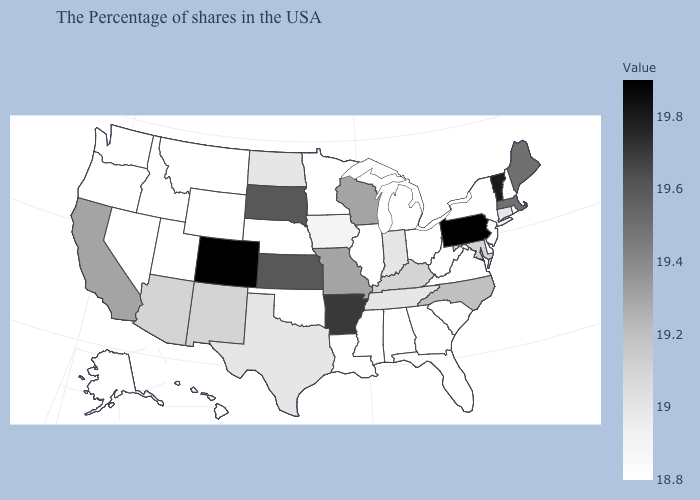Which states have the highest value in the USA?
Answer briefly. Pennsylvania, Colorado. Does South Dakota have the highest value in the MidWest?
Short answer required. Yes. Among the states that border West Virginia , does Kentucky have the highest value?
Be succinct. No. Does Idaho have the lowest value in the USA?
Short answer required. Yes. Does Georgia have the lowest value in the South?
Be succinct. Yes. Does Alaska have the lowest value in the USA?
Short answer required. Yes. Does Connecticut have the lowest value in the Northeast?
Concise answer only. No. Does Alaska have the highest value in the USA?
Give a very brief answer. No. Which states hav the highest value in the MidWest?
Write a very short answer. Kansas, South Dakota. Which states have the lowest value in the USA?
Short answer required. Rhode Island, New Hampshire, New York, New Jersey, Delaware, Virginia, South Carolina, West Virginia, Ohio, Florida, Georgia, Michigan, Alabama, Illinois, Mississippi, Louisiana, Minnesota, Nebraska, Oklahoma, Wyoming, Utah, Montana, Idaho, Nevada, Washington, Oregon, Alaska, Hawaii. 